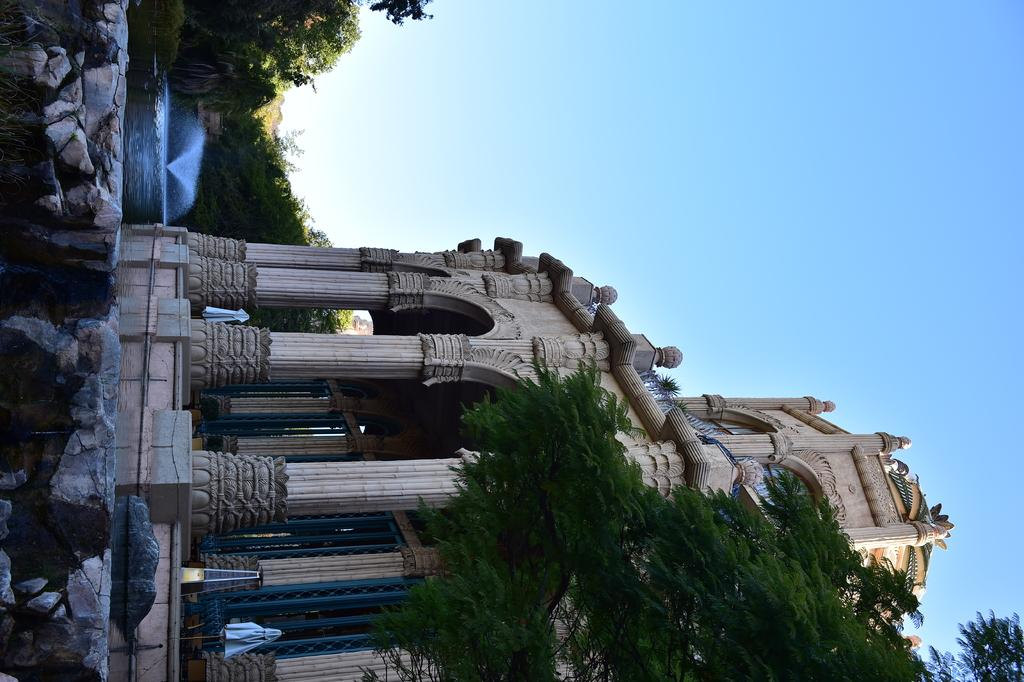What type of structure is in the image? There is a building in the image. What architectural feature can be seen on the building? The building has pillars. What is located at the bottom of the image? There is a tree at the bottom of the image. What can be seen in the background of the image? There are many trees and water visible in the background of the image. What is visible at the top of the image? The sky is visible at the top of the image. What type of motion can be seen in the image? There is no motion visible in the image; it is a still photograph. 